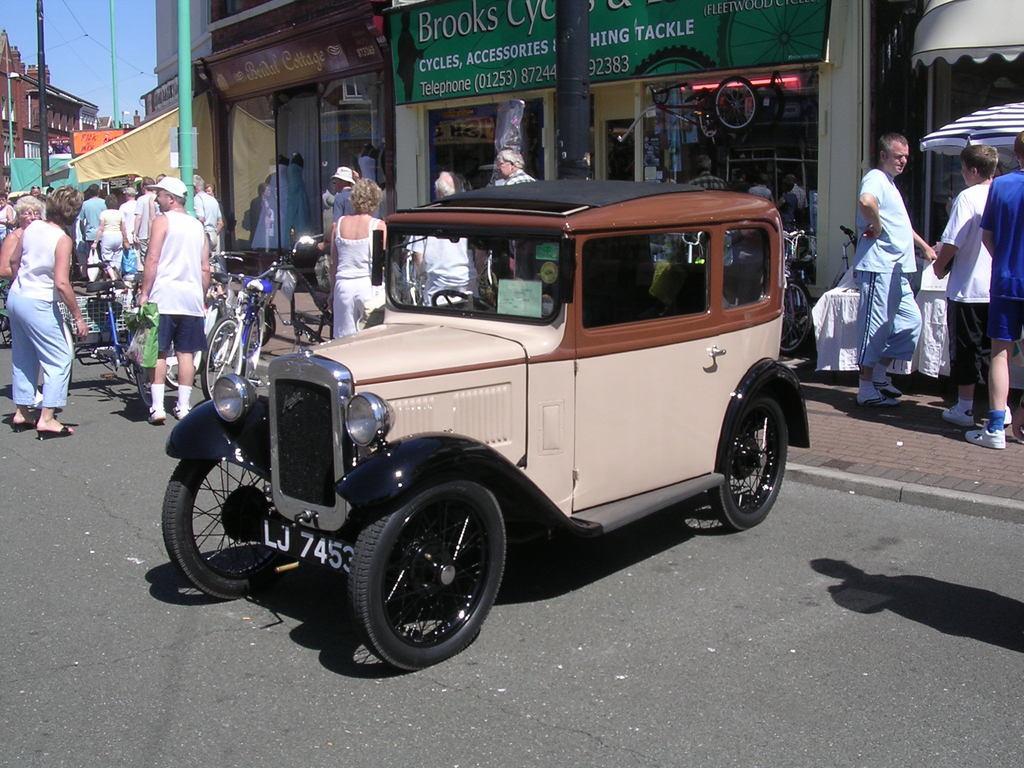Please provide a concise description of this image. In this image I can see the group of people, bicycles and vehicle on the road. To the side of the road I can see the few more people, poles and the buildings with boards. In the background I can see the sky. 